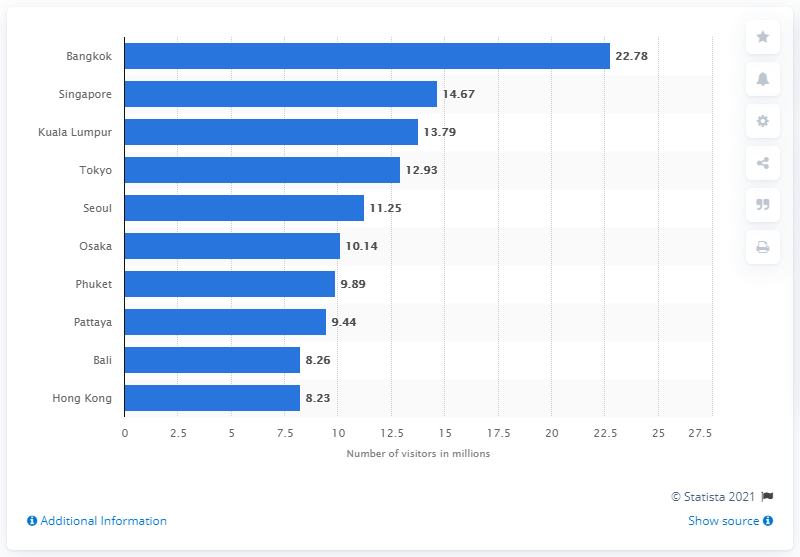How does the number of visitors to Bangkok compare to Hong Kong? Bangkok had significantly more visitors compared to Hong Kong in 2018. The image shows Bangkok with 22.78 million visitors, whereas Hong Kong had 8.23 million, nearly a third of Bangkok's total. 